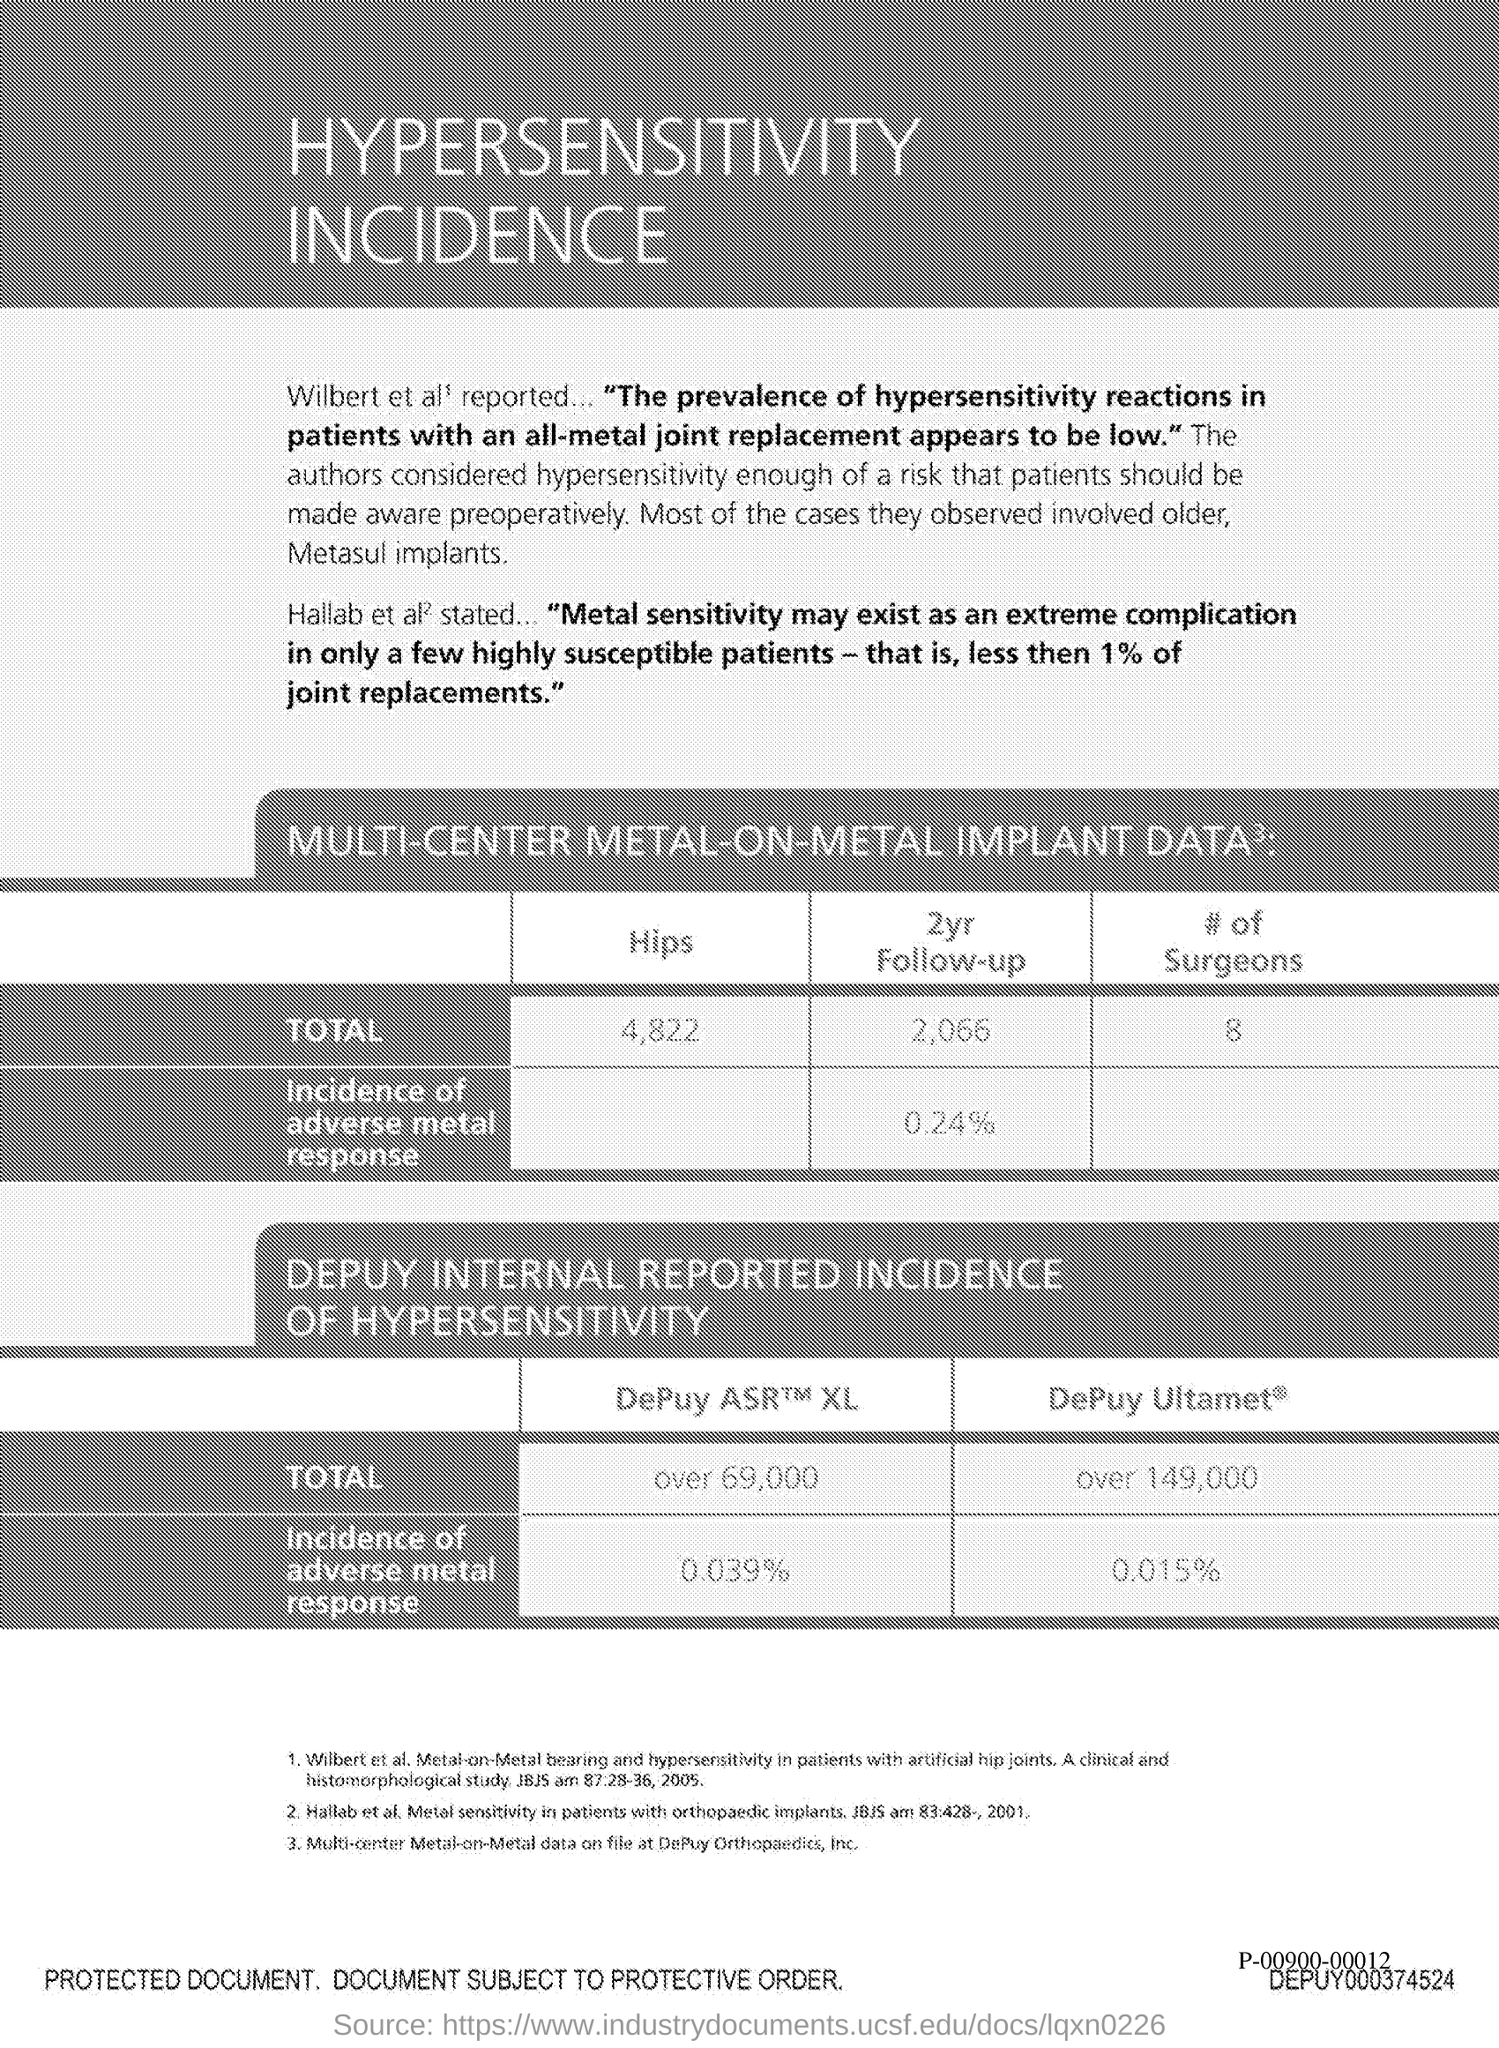Indicate a few pertinent items in this graphic. The total number of hips is 4,822. The title of the document is "HyperSensitivity Incidence". 